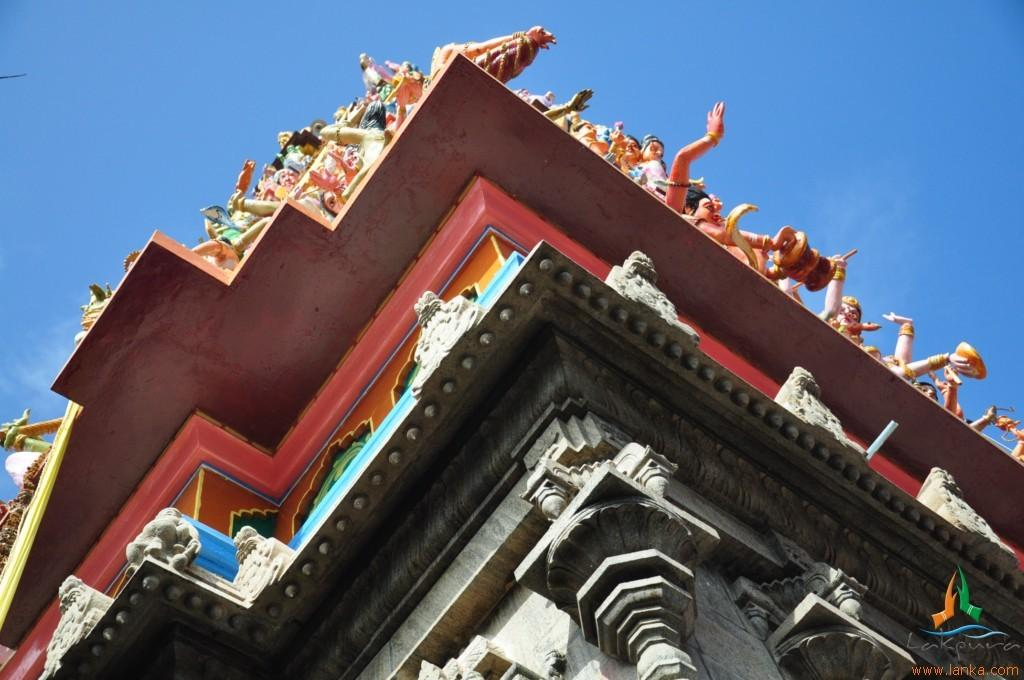What type of structure is located at the bottom of the image? There is a temple at the bottom of the image. What can be seen on the temple? The temple has sculptures on it. What is visible at the top of the image? The sky is visible at the top of the image. What type of activity is taking place in the tank in the image? There is no tank present in the image; it features a temple with sculptures. What month is it in the image? The month cannot be determined from the image, as it only shows a temple with sculptures and the sky. 